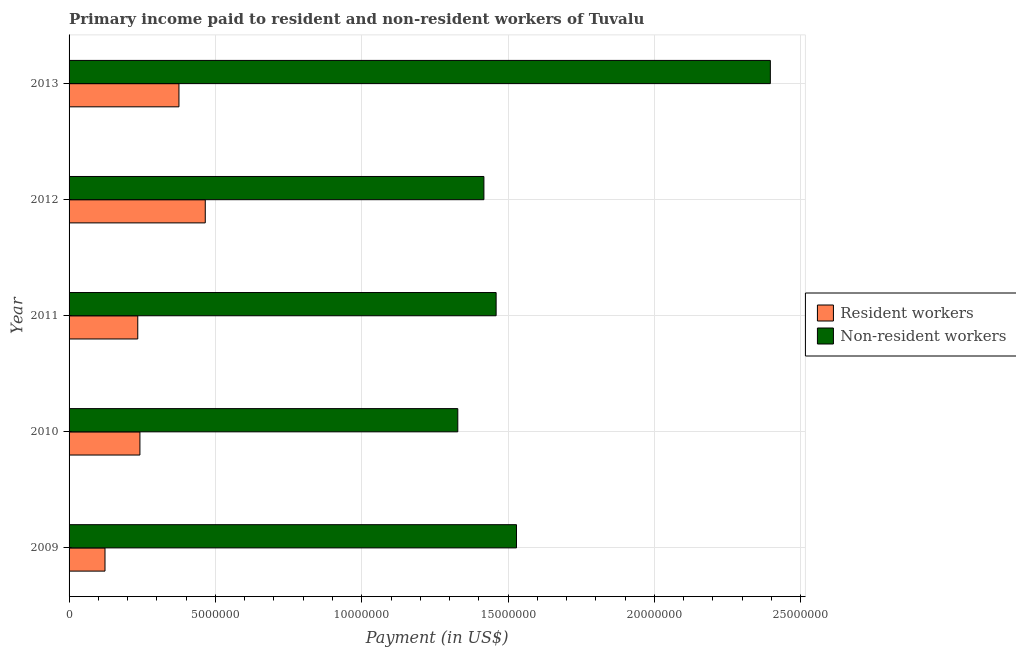How many different coloured bars are there?
Ensure brevity in your answer.  2. How many groups of bars are there?
Make the answer very short. 5. Are the number of bars per tick equal to the number of legend labels?
Your answer should be compact. Yes. Are the number of bars on each tick of the Y-axis equal?
Your response must be concise. Yes. In how many cases, is the number of bars for a given year not equal to the number of legend labels?
Provide a short and direct response. 0. What is the payment made to resident workers in 2011?
Offer a very short reply. 2.35e+06. Across all years, what is the maximum payment made to non-resident workers?
Your answer should be very brief. 2.40e+07. Across all years, what is the minimum payment made to resident workers?
Your answer should be compact. 1.23e+06. What is the total payment made to non-resident workers in the graph?
Keep it short and to the point. 8.13e+07. What is the difference between the payment made to resident workers in 2012 and that in 2013?
Offer a very short reply. 8.99e+05. What is the difference between the payment made to resident workers in 2010 and the payment made to non-resident workers in 2013?
Keep it short and to the point. -2.15e+07. What is the average payment made to non-resident workers per year?
Give a very brief answer. 1.63e+07. In the year 2013, what is the difference between the payment made to resident workers and payment made to non-resident workers?
Ensure brevity in your answer.  -2.02e+07. What is the ratio of the payment made to resident workers in 2010 to that in 2011?
Keep it short and to the point. 1.03. What is the difference between the highest and the second highest payment made to resident workers?
Offer a terse response. 8.99e+05. What is the difference between the highest and the lowest payment made to non-resident workers?
Keep it short and to the point. 1.07e+07. What does the 2nd bar from the top in 2012 represents?
Provide a short and direct response. Resident workers. What does the 2nd bar from the bottom in 2013 represents?
Make the answer very short. Non-resident workers. How many bars are there?
Your answer should be compact. 10. What is the difference between two consecutive major ticks on the X-axis?
Keep it short and to the point. 5.00e+06. How many legend labels are there?
Give a very brief answer. 2. How are the legend labels stacked?
Provide a succinct answer. Vertical. What is the title of the graph?
Provide a succinct answer. Primary income paid to resident and non-resident workers of Tuvalu. Does "Fraud firms" appear as one of the legend labels in the graph?
Offer a very short reply. No. What is the label or title of the X-axis?
Provide a succinct answer. Payment (in US$). What is the Payment (in US$) of Resident workers in 2009?
Your response must be concise. 1.23e+06. What is the Payment (in US$) in Non-resident workers in 2009?
Provide a succinct answer. 1.53e+07. What is the Payment (in US$) in Resident workers in 2010?
Offer a terse response. 2.42e+06. What is the Payment (in US$) of Non-resident workers in 2010?
Offer a very short reply. 1.33e+07. What is the Payment (in US$) in Resident workers in 2011?
Keep it short and to the point. 2.35e+06. What is the Payment (in US$) in Non-resident workers in 2011?
Your answer should be very brief. 1.46e+07. What is the Payment (in US$) of Resident workers in 2012?
Your answer should be very brief. 4.65e+06. What is the Payment (in US$) in Non-resident workers in 2012?
Provide a short and direct response. 1.42e+07. What is the Payment (in US$) of Resident workers in 2013?
Make the answer very short. 3.75e+06. What is the Payment (in US$) in Non-resident workers in 2013?
Ensure brevity in your answer.  2.40e+07. Across all years, what is the maximum Payment (in US$) in Resident workers?
Give a very brief answer. 4.65e+06. Across all years, what is the maximum Payment (in US$) in Non-resident workers?
Offer a terse response. 2.40e+07. Across all years, what is the minimum Payment (in US$) of Resident workers?
Offer a terse response. 1.23e+06. Across all years, what is the minimum Payment (in US$) of Non-resident workers?
Give a very brief answer. 1.33e+07. What is the total Payment (in US$) in Resident workers in the graph?
Your response must be concise. 1.44e+07. What is the total Payment (in US$) of Non-resident workers in the graph?
Offer a terse response. 8.13e+07. What is the difference between the Payment (in US$) in Resident workers in 2009 and that in 2010?
Provide a short and direct response. -1.19e+06. What is the difference between the Payment (in US$) of Non-resident workers in 2009 and that in 2010?
Your answer should be compact. 2.01e+06. What is the difference between the Payment (in US$) of Resident workers in 2009 and that in 2011?
Offer a terse response. -1.12e+06. What is the difference between the Payment (in US$) in Non-resident workers in 2009 and that in 2011?
Make the answer very short. 6.95e+05. What is the difference between the Payment (in US$) of Resident workers in 2009 and that in 2012?
Ensure brevity in your answer.  -3.43e+06. What is the difference between the Payment (in US$) in Non-resident workers in 2009 and that in 2012?
Ensure brevity in your answer.  1.11e+06. What is the difference between the Payment (in US$) in Resident workers in 2009 and that in 2013?
Provide a succinct answer. -2.53e+06. What is the difference between the Payment (in US$) of Non-resident workers in 2009 and that in 2013?
Your response must be concise. -8.67e+06. What is the difference between the Payment (in US$) of Resident workers in 2010 and that in 2011?
Your response must be concise. 7.36e+04. What is the difference between the Payment (in US$) in Non-resident workers in 2010 and that in 2011?
Provide a short and direct response. -1.31e+06. What is the difference between the Payment (in US$) of Resident workers in 2010 and that in 2012?
Offer a very short reply. -2.23e+06. What is the difference between the Payment (in US$) of Non-resident workers in 2010 and that in 2012?
Make the answer very short. -8.92e+05. What is the difference between the Payment (in US$) of Resident workers in 2010 and that in 2013?
Give a very brief answer. -1.33e+06. What is the difference between the Payment (in US$) in Non-resident workers in 2010 and that in 2013?
Keep it short and to the point. -1.07e+07. What is the difference between the Payment (in US$) of Resident workers in 2011 and that in 2012?
Provide a succinct answer. -2.31e+06. What is the difference between the Payment (in US$) in Non-resident workers in 2011 and that in 2012?
Your response must be concise. 4.18e+05. What is the difference between the Payment (in US$) in Resident workers in 2011 and that in 2013?
Make the answer very short. -1.41e+06. What is the difference between the Payment (in US$) in Non-resident workers in 2011 and that in 2013?
Your response must be concise. -9.37e+06. What is the difference between the Payment (in US$) in Resident workers in 2012 and that in 2013?
Your answer should be compact. 8.99e+05. What is the difference between the Payment (in US$) in Non-resident workers in 2012 and that in 2013?
Offer a terse response. -9.79e+06. What is the difference between the Payment (in US$) in Resident workers in 2009 and the Payment (in US$) in Non-resident workers in 2010?
Your response must be concise. -1.21e+07. What is the difference between the Payment (in US$) of Resident workers in 2009 and the Payment (in US$) of Non-resident workers in 2011?
Make the answer very short. -1.34e+07. What is the difference between the Payment (in US$) in Resident workers in 2009 and the Payment (in US$) in Non-resident workers in 2012?
Provide a short and direct response. -1.29e+07. What is the difference between the Payment (in US$) in Resident workers in 2009 and the Payment (in US$) in Non-resident workers in 2013?
Your answer should be very brief. -2.27e+07. What is the difference between the Payment (in US$) in Resident workers in 2010 and the Payment (in US$) in Non-resident workers in 2011?
Provide a short and direct response. -1.22e+07. What is the difference between the Payment (in US$) of Resident workers in 2010 and the Payment (in US$) of Non-resident workers in 2012?
Make the answer very short. -1.18e+07. What is the difference between the Payment (in US$) in Resident workers in 2010 and the Payment (in US$) in Non-resident workers in 2013?
Your answer should be compact. -2.15e+07. What is the difference between the Payment (in US$) in Resident workers in 2011 and the Payment (in US$) in Non-resident workers in 2012?
Offer a very short reply. -1.18e+07. What is the difference between the Payment (in US$) of Resident workers in 2011 and the Payment (in US$) of Non-resident workers in 2013?
Offer a very short reply. -2.16e+07. What is the difference between the Payment (in US$) of Resident workers in 2012 and the Payment (in US$) of Non-resident workers in 2013?
Provide a short and direct response. -1.93e+07. What is the average Payment (in US$) of Resident workers per year?
Your answer should be compact. 2.88e+06. What is the average Payment (in US$) of Non-resident workers per year?
Ensure brevity in your answer.  1.63e+07. In the year 2009, what is the difference between the Payment (in US$) in Resident workers and Payment (in US$) in Non-resident workers?
Offer a very short reply. -1.41e+07. In the year 2010, what is the difference between the Payment (in US$) of Resident workers and Payment (in US$) of Non-resident workers?
Your answer should be compact. -1.09e+07. In the year 2011, what is the difference between the Payment (in US$) of Resident workers and Payment (in US$) of Non-resident workers?
Give a very brief answer. -1.22e+07. In the year 2012, what is the difference between the Payment (in US$) in Resident workers and Payment (in US$) in Non-resident workers?
Provide a short and direct response. -9.52e+06. In the year 2013, what is the difference between the Payment (in US$) in Resident workers and Payment (in US$) in Non-resident workers?
Provide a short and direct response. -2.02e+07. What is the ratio of the Payment (in US$) in Resident workers in 2009 to that in 2010?
Offer a terse response. 0.51. What is the ratio of the Payment (in US$) of Non-resident workers in 2009 to that in 2010?
Ensure brevity in your answer.  1.15. What is the ratio of the Payment (in US$) of Resident workers in 2009 to that in 2011?
Your answer should be very brief. 0.52. What is the ratio of the Payment (in US$) in Non-resident workers in 2009 to that in 2011?
Give a very brief answer. 1.05. What is the ratio of the Payment (in US$) in Resident workers in 2009 to that in 2012?
Make the answer very short. 0.26. What is the ratio of the Payment (in US$) in Non-resident workers in 2009 to that in 2012?
Keep it short and to the point. 1.08. What is the ratio of the Payment (in US$) in Resident workers in 2009 to that in 2013?
Your response must be concise. 0.33. What is the ratio of the Payment (in US$) in Non-resident workers in 2009 to that in 2013?
Your response must be concise. 0.64. What is the ratio of the Payment (in US$) of Resident workers in 2010 to that in 2011?
Your response must be concise. 1.03. What is the ratio of the Payment (in US$) in Non-resident workers in 2010 to that in 2011?
Provide a short and direct response. 0.91. What is the ratio of the Payment (in US$) in Resident workers in 2010 to that in 2012?
Provide a succinct answer. 0.52. What is the ratio of the Payment (in US$) of Non-resident workers in 2010 to that in 2012?
Your answer should be compact. 0.94. What is the ratio of the Payment (in US$) of Resident workers in 2010 to that in 2013?
Your response must be concise. 0.64. What is the ratio of the Payment (in US$) of Non-resident workers in 2010 to that in 2013?
Provide a short and direct response. 0.55. What is the ratio of the Payment (in US$) in Resident workers in 2011 to that in 2012?
Provide a succinct answer. 0.5. What is the ratio of the Payment (in US$) of Non-resident workers in 2011 to that in 2012?
Your answer should be very brief. 1.03. What is the ratio of the Payment (in US$) in Resident workers in 2011 to that in 2013?
Offer a very short reply. 0.63. What is the ratio of the Payment (in US$) in Non-resident workers in 2011 to that in 2013?
Make the answer very short. 0.61. What is the ratio of the Payment (in US$) in Resident workers in 2012 to that in 2013?
Your answer should be very brief. 1.24. What is the ratio of the Payment (in US$) of Non-resident workers in 2012 to that in 2013?
Your response must be concise. 0.59. What is the difference between the highest and the second highest Payment (in US$) in Resident workers?
Your answer should be compact. 8.99e+05. What is the difference between the highest and the second highest Payment (in US$) in Non-resident workers?
Your answer should be compact. 8.67e+06. What is the difference between the highest and the lowest Payment (in US$) of Resident workers?
Offer a very short reply. 3.43e+06. What is the difference between the highest and the lowest Payment (in US$) in Non-resident workers?
Your answer should be very brief. 1.07e+07. 